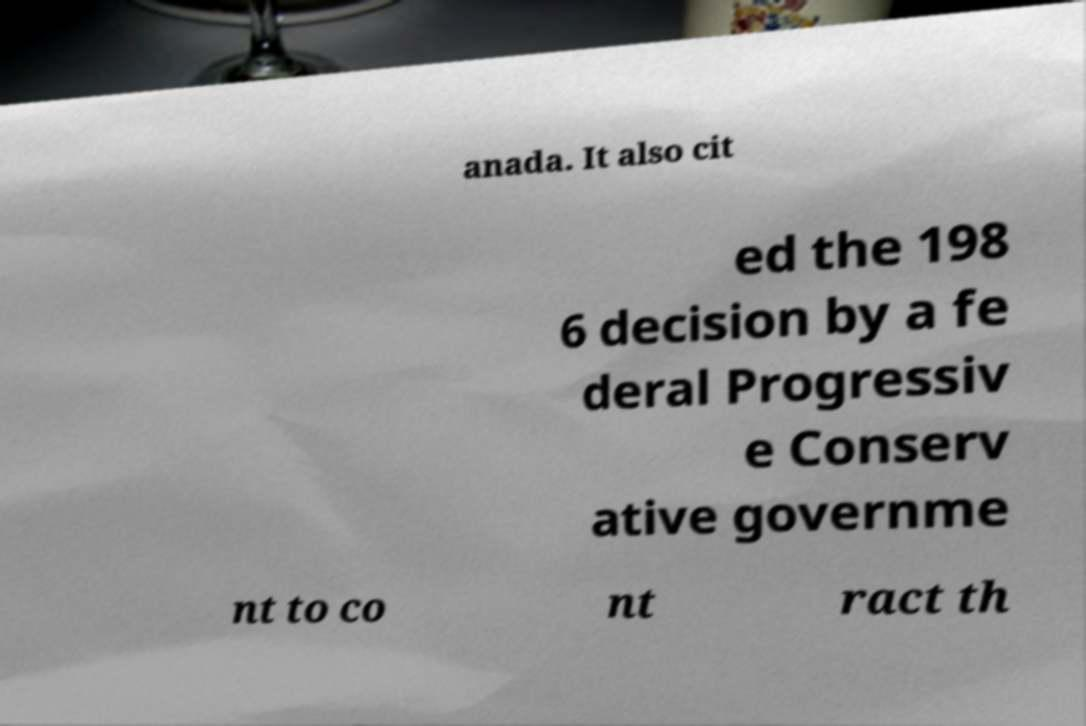Could you assist in decoding the text presented in this image and type it out clearly? anada. It also cit ed the 198 6 decision by a fe deral Progressiv e Conserv ative governme nt to co nt ract th 